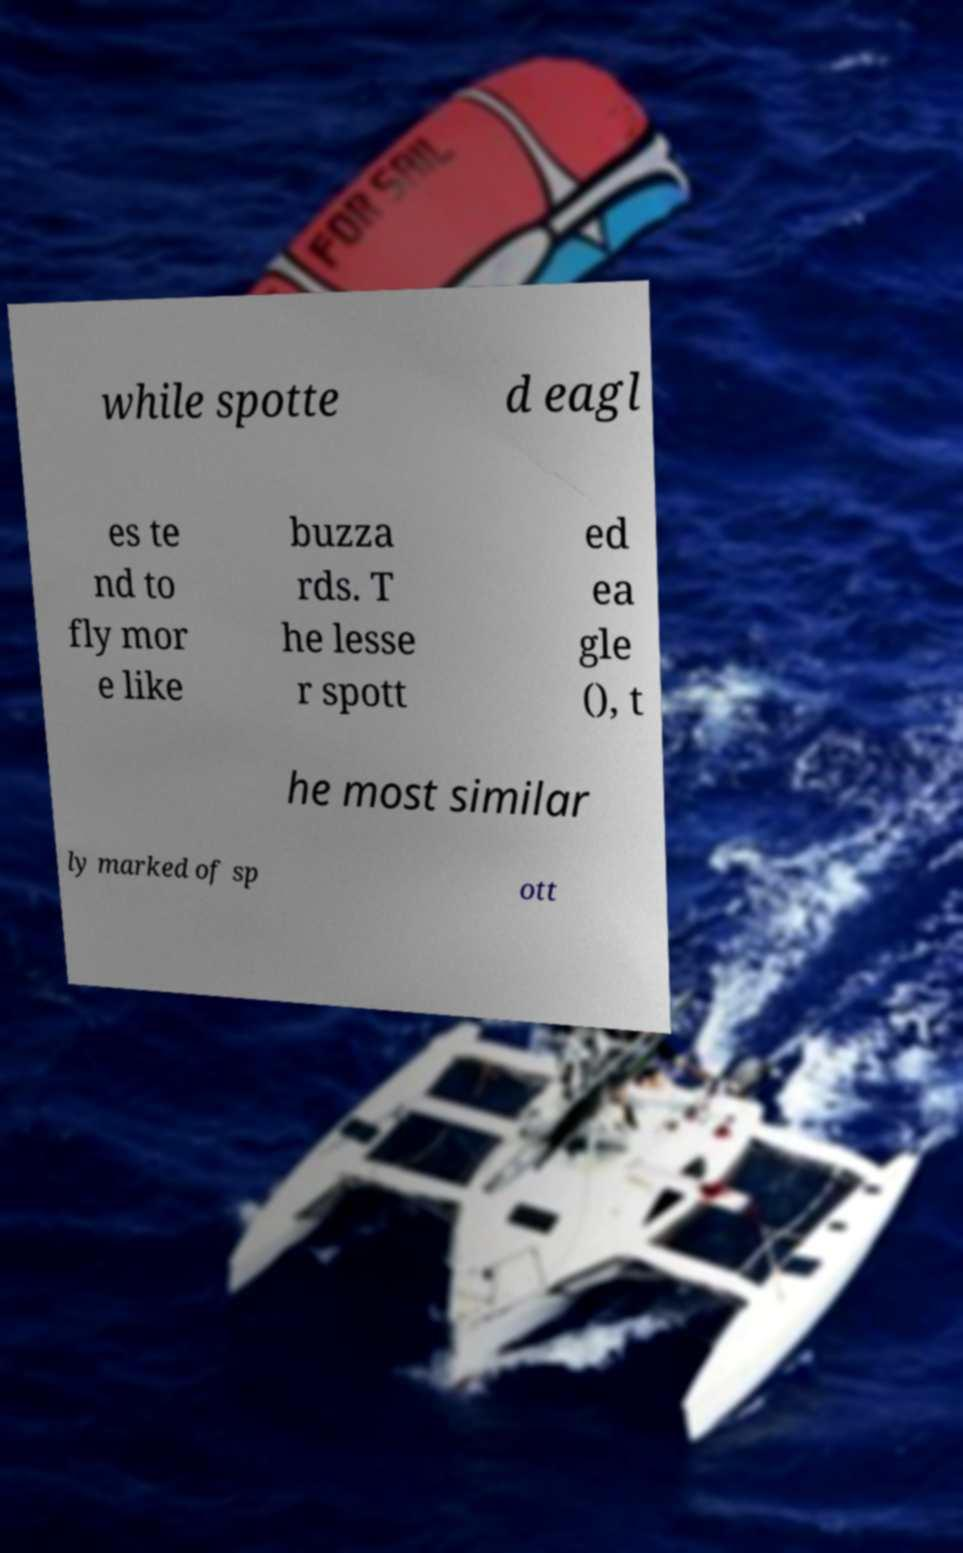For documentation purposes, I need the text within this image transcribed. Could you provide that? while spotte d eagl es te nd to fly mor e like buzza rds. T he lesse r spott ed ea gle (), t he most similar ly marked of sp ott 